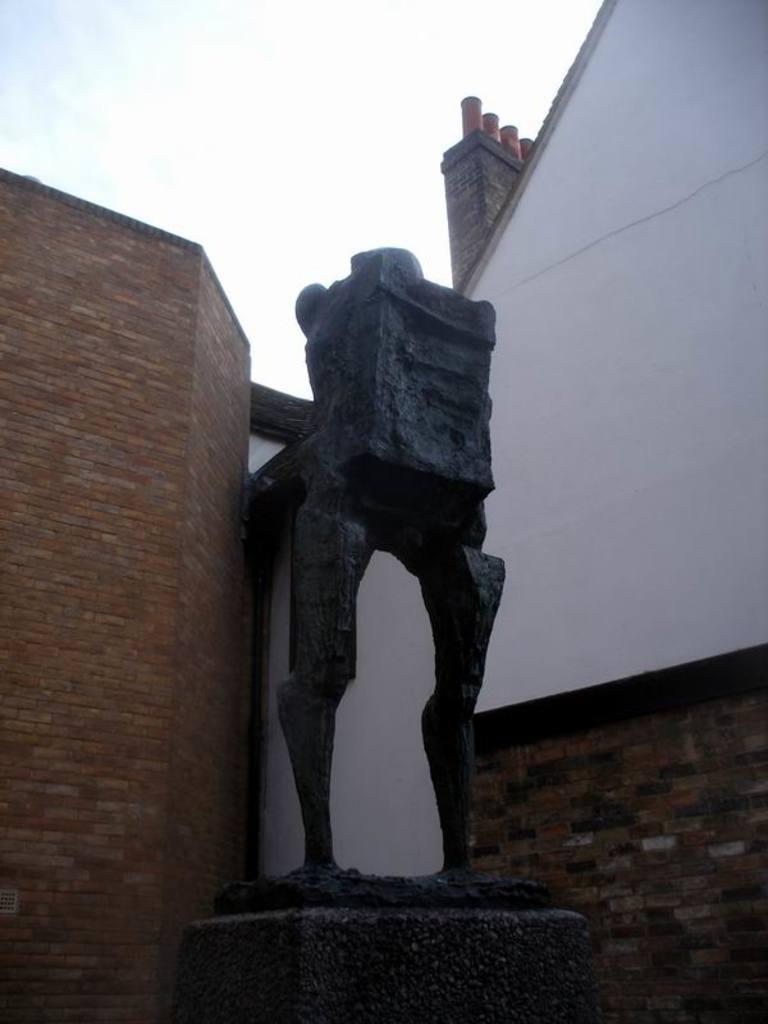In one or two sentences, can you explain what this image depicts? In the image we can see a sculpture made up of stones and the building made up of bricks. We can even a sky. 